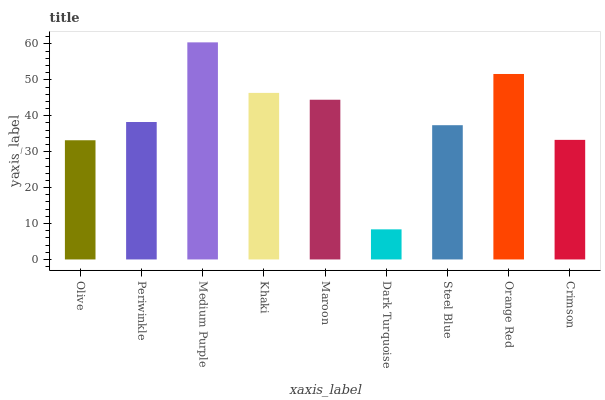Is Dark Turquoise the minimum?
Answer yes or no. Yes. Is Medium Purple the maximum?
Answer yes or no. Yes. Is Periwinkle the minimum?
Answer yes or no. No. Is Periwinkle the maximum?
Answer yes or no. No. Is Periwinkle greater than Olive?
Answer yes or no. Yes. Is Olive less than Periwinkle?
Answer yes or no. Yes. Is Olive greater than Periwinkle?
Answer yes or no. No. Is Periwinkle less than Olive?
Answer yes or no. No. Is Periwinkle the high median?
Answer yes or no. Yes. Is Periwinkle the low median?
Answer yes or no. Yes. Is Maroon the high median?
Answer yes or no. No. Is Maroon the low median?
Answer yes or no. No. 